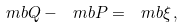Convert formula to latex. <formula><loc_0><loc_0><loc_500><loc_500>\ m b { Q } - \ m b { P } = \ m b { \xi } \, ,</formula> 